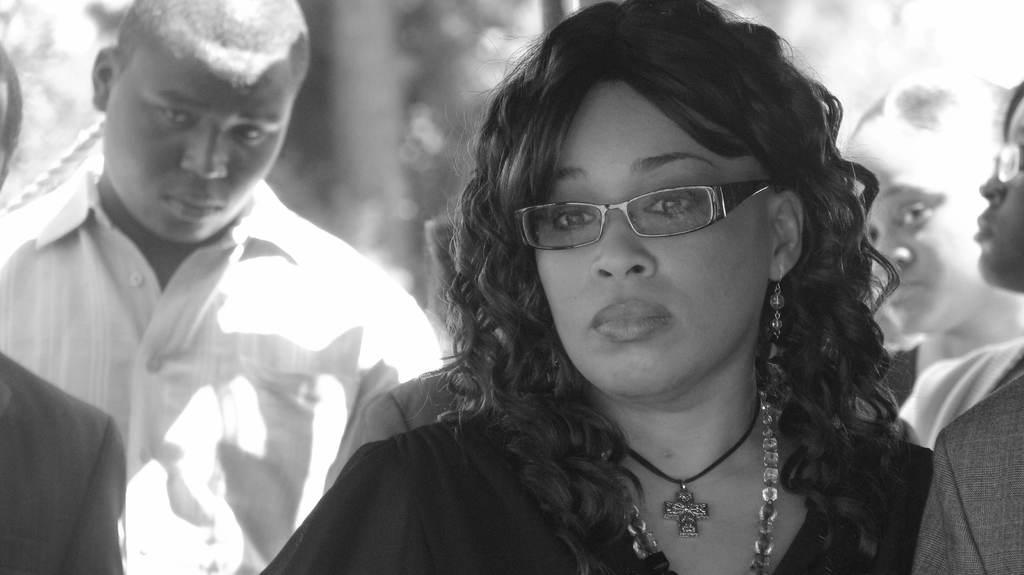What is the color scheme of the image? The image is black and white. Who is the main subject in the foreground of the image? There is a woman in the foreground of the image. Can you describe the surrounding environment of the woman? There are other people around the woman in the image. What type of elbow is visible in the image? There is no elbow present in the image. Is there any eggnog being served in the image? There is no mention of eggnog in the image. 